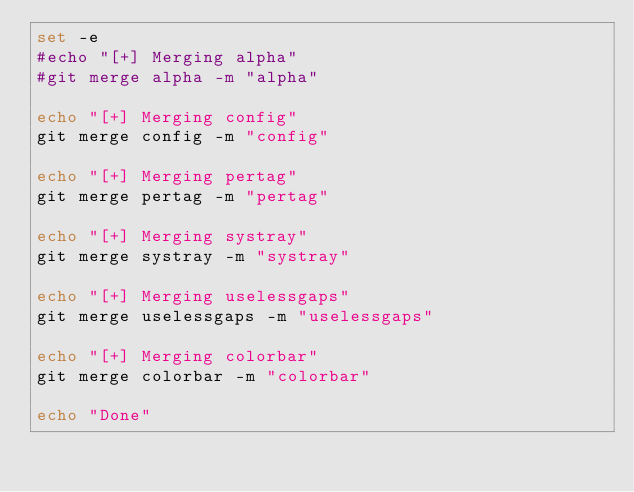<code> <loc_0><loc_0><loc_500><loc_500><_Bash_>set -e
#echo "[+] Merging alpha"
#git merge alpha -m "alpha"

echo "[+] Merging config"
git merge config -m "config"

echo "[+] Merging pertag"
git merge pertag -m "pertag"

echo "[+] Merging systray"
git merge systray -m "systray"

echo "[+] Merging uselessgaps"
git merge uselessgaps -m "uselessgaps"

echo "[+] Merging colorbar"
git merge colorbar -m "colorbar"

echo "Done"
</code> 